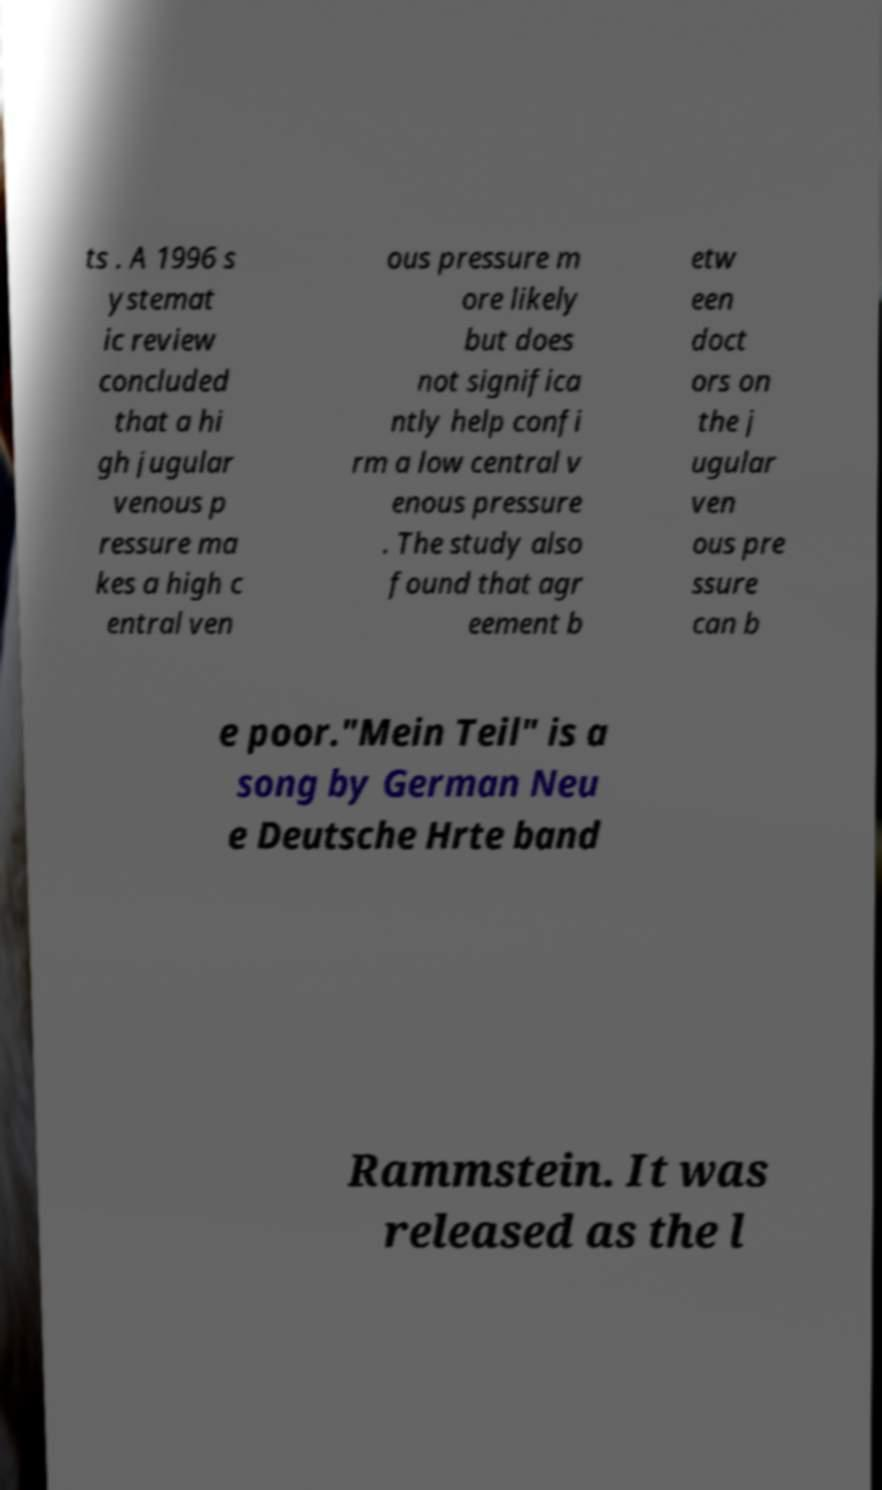There's text embedded in this image that I need extracted. Can you transcribe it verbatim? ts . A 1996 s ystemat ic review concluded that a hi gh jugular venous p ressure ma kes a high c entral ven ous pressure m ore likely but does not significa ntly help confi rm a low central v enous pressure . The study also found that agr eement b etw een doct ors on the j ugular ven ous pre ssure can b e poor."Mein Teil" is a song by German Neu e Deutsche Hrte band Rammstein. It was released as the l 